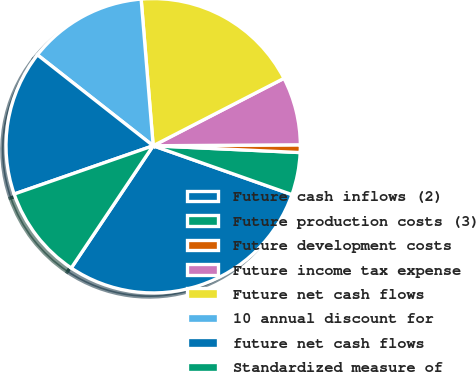Convert chart. <chart><loc_0><loc_0><loc_500><loc_500><pie_chart><fcel>Future cash inflows (2)<fcel>Future production costs (3)<fcel>Future development costs<fcel>Future income tax expense<fcel>Future net cash flows<fcel>10 annual discount for<fcel>future net cash flows<fcel>Standardized measure of<nl><fcel>29.01%<fcel>4.65%<fcel>0.84%<fcel>7.47%<fcel>18.73%<fcel>13.1%<fcel>15.92%<fcel>10.28%<nl></chart> 